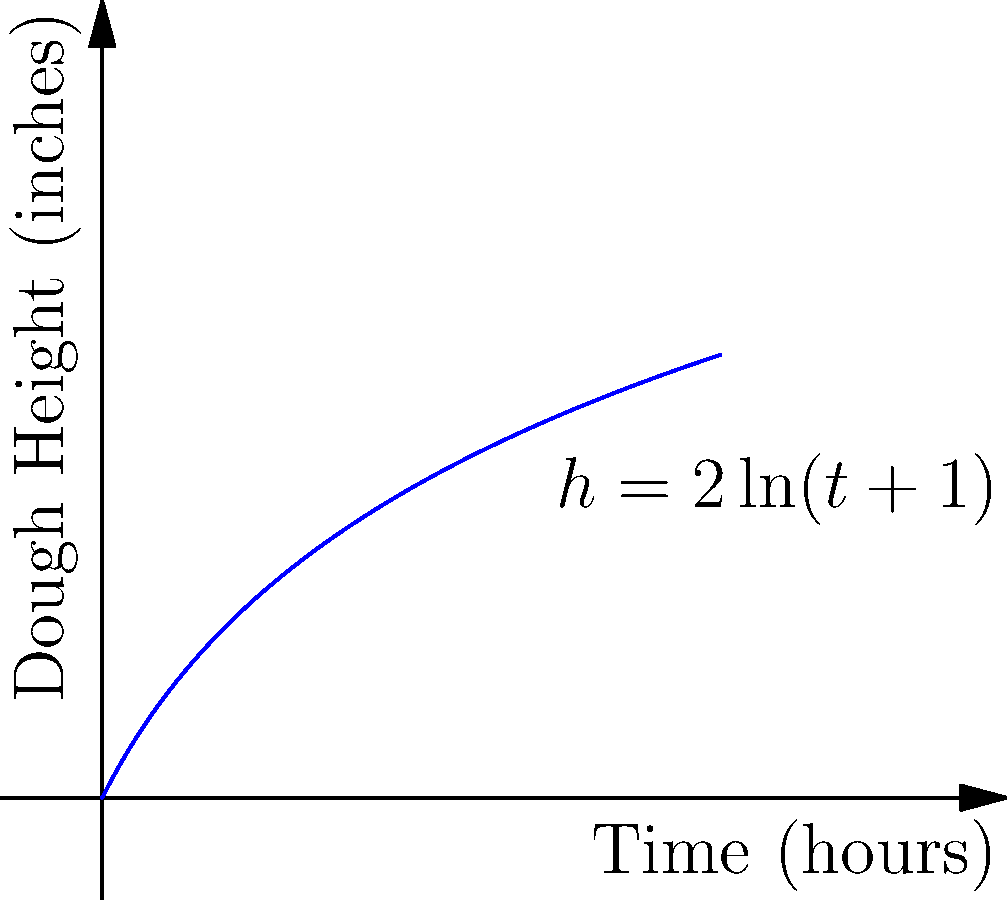As a chef specializing in Chicago-style deep-dish pizza, you're experimenting with a new dough recipe. The height $h$ (in inches) of the dough as it rises over time $t$ (in hours) is modeled by the function $h(t) = 2\ln(t+1)$. At what rate (in inches per hour) is the dough rising after 2 hours? To find the rate at which the dough is rising after 2 hours, we need to calculate the derivative of the function $h(t)$ and evaluate it at $t=2$. Here's the step-by-step process:

1) The given function is $h(t) = 2\ln(t+1)$

2) To find the derivative, we use the chain rule:
   $\frac{dh}{dt} = 2 \cdot \frac{d}{dt}[\ln(t+1)]$

3) The derivative of $\ln(x)$ is $\frac{1}{x}$, so:
   $\frac{dh}{dt} = 2 \cdot \frac{1}{t+1}$

4) Simplify:
   $\frac{dh}{dt} = \frac{2}{t+1}$

5) Now, we evaluate this at $t=2$:
   $\frac{dh}{dt}|_{t=2} = \frac{2}{2+1} = \frac{2}{3}$

Therefore, after 2 hours, the dough is rising at a rate of $\frac{2}{3}$ inches per hour.
Answer: $\frac{2}{3}$ inches per hour 